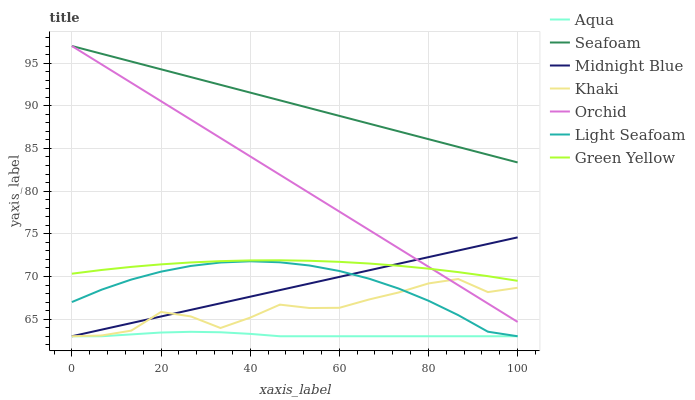Does Aqua have the minimum area under the curve?
Answer yes or no. Yes. Does Seafoam have the maximum area under the curve?
Answer yes or no. Yes. Does Midnight Blue have the minimum area under the curve?
Answer yes or no. No. Does Midnight Blue have the maximum area under the curve?
Answer yes or no. No. Is Midnight Blue the smoothest?
Answer yes or no. Yes. Is Khaki the roughest?
Answer yes or no. Yes. Is Aqua the smoothest?
Answer yes or no. No. Is Aqua the roughest?
Answer yes or no. No. Does Khaki have the lowest value?
Answer yes or no. Yes. Does Seafoam have the lowest value?
Answer yes or no. No. Does Orchid have the highest value?
Answer yes or no. Yes. Does Midnight Blue have the highest value?
Answer yes or no. No. Is Khaki less than Green Yellow?
Answer yes or no. Yes. Is Green Yellow greater than Khaki?
Answer yes or no. Yes. Does Midnight Blue intersect Aqua?
Answer yes or no. Yes. Is Midnight Blue less than Aqua?
Answer yes or no. No. Is Midnight Blue greater than Aqua?
Answer yes or no. No. Does Khaki intersect Green Yellow?
Answer yes or no. No. 